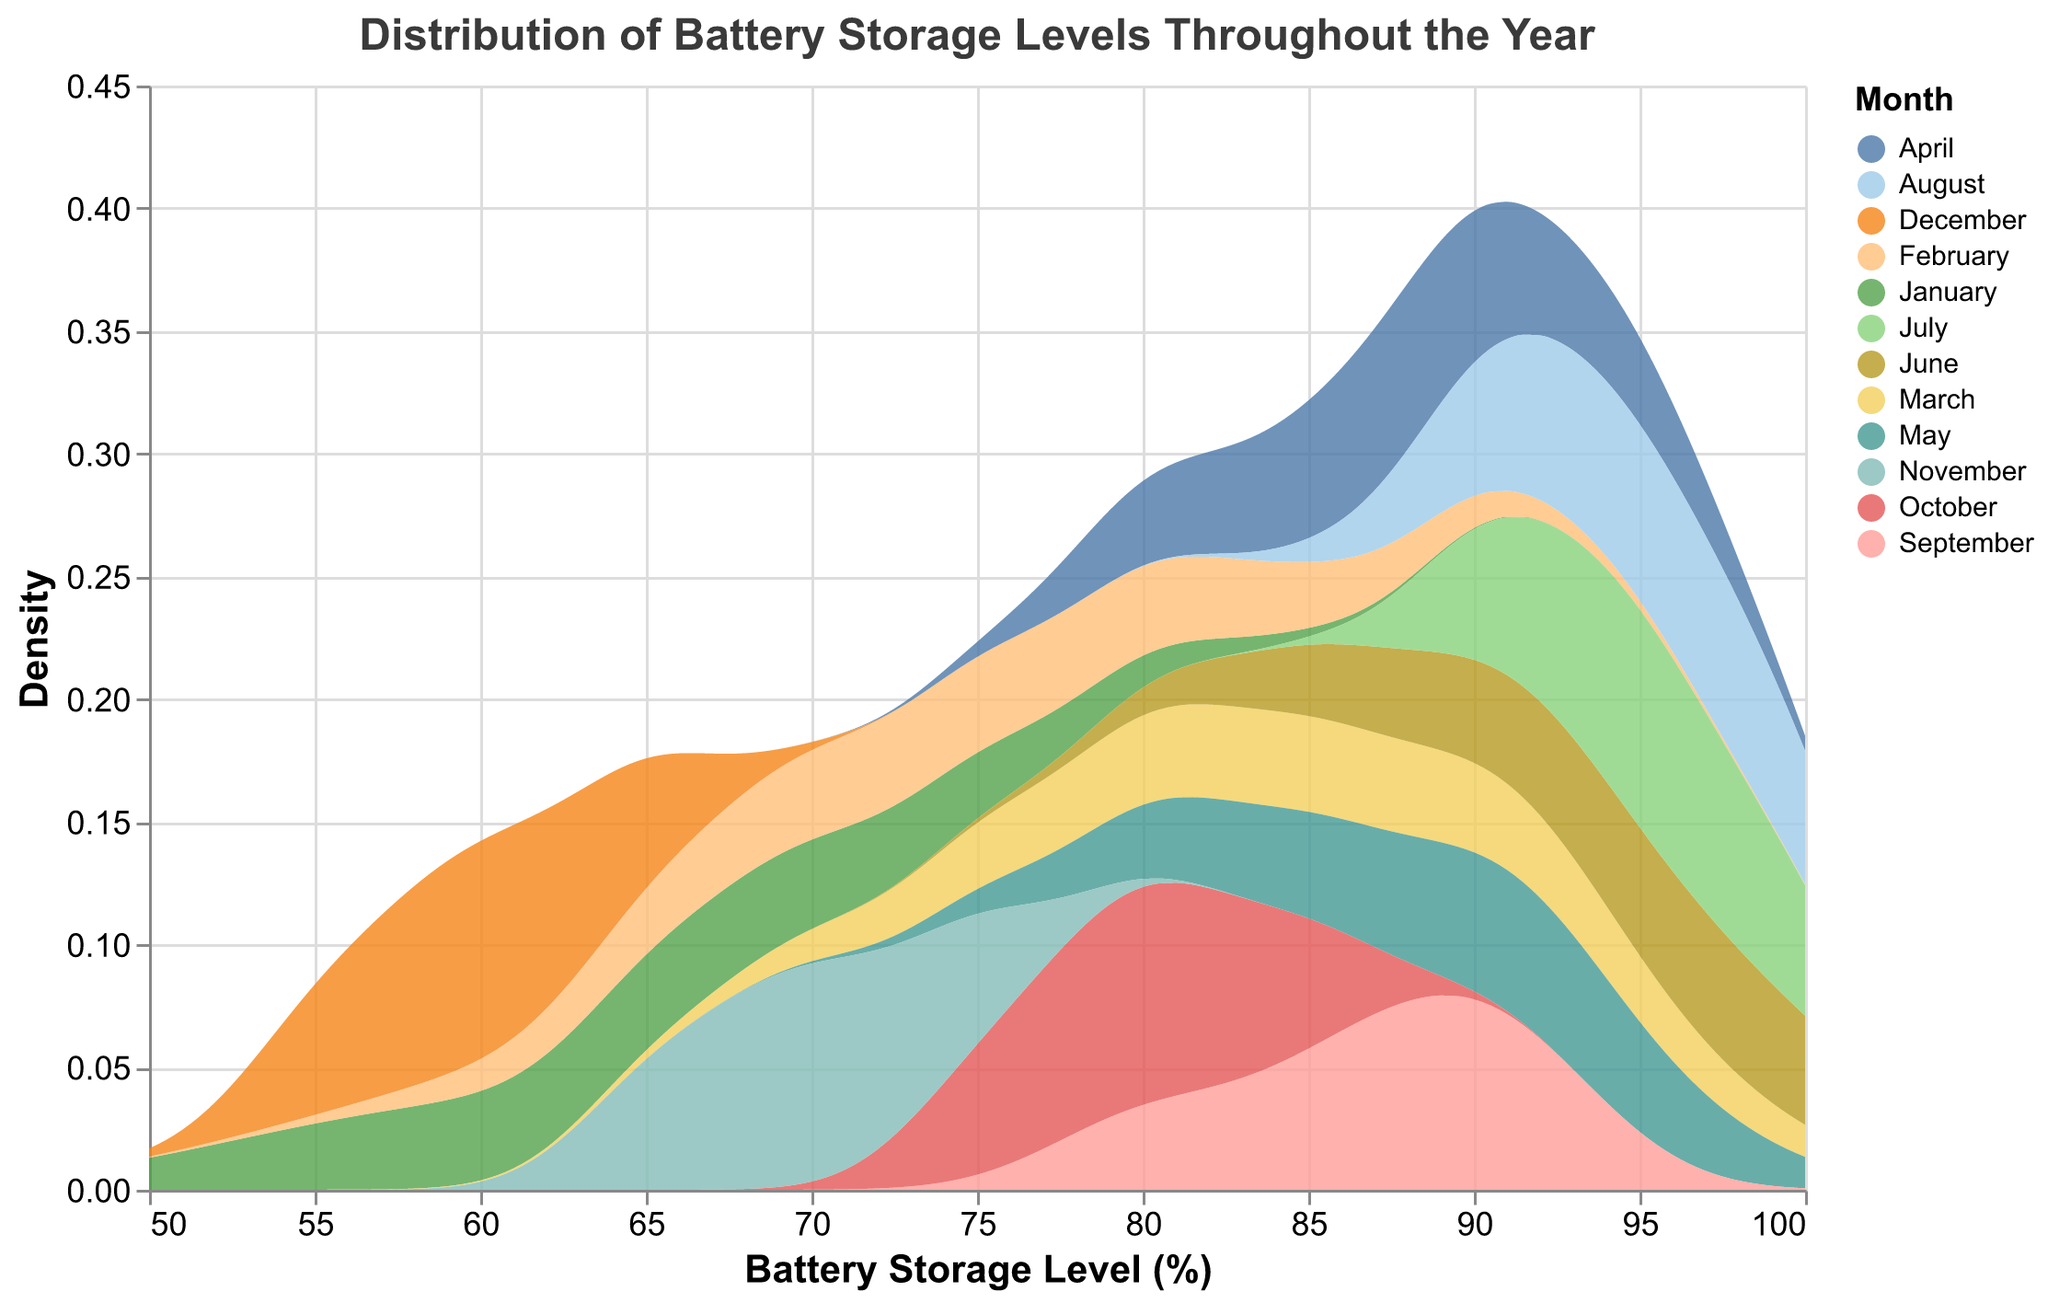What is the title of the plot? The title is displayed at the top of the plot and reads "Distribution of Battery Storage Levels Throughout the Year."
Answer: Distribution of Battery Storage Levels Throughout the Year What does the x-axis represent in the plot? The x-axis label shows "Battery Storage Level (%)" indicating that the x-axis represents the percentage level of battery storage.
Answer: Battery Storage Level (%) What is the color used to represent each month? The legend on the right side of the plot specifies the color representation for each month.
Answer: Various colors specified by the legend Which month shows the highest density of battery storage levels around 100%? Looking at the peak of density curves around the 100% mark, both June, July, and August have peaks, implying these months have high densities at 100%.
Answer: June, July, and August During which months do battery storage levels show the lowest density values around 55%? Referring to the density curves near the 55% mark, January and December show curves starting near 55% but with lower density values, indicating lower occurrences.
Answer: January and December What can be inferred about battery storage levels in summer months (June, July, and August)? The density curves for June, July, and August are higher and shift towards the upper end (near 100%), indicating higher battery storage levels during summer months.
Answer: Higher battery storage levels Which months exhibit battery storage levels with a prominent peak at around 85%? By observing the density curves, April and September show notable peaks around the 85% level.
Answer: April and September How does the variability of battery storage levels in December compare to those in March? December's density curve shows a narrower range and lower densities compared to March, which shows wider distribution peaks around mid and upper levels.
Answer: December has lower variability compared to March In which month does the density of battery storage levels hover around 70% most prominently? The density curve for November prominently peaks around the 70% mark, indicating higher frequency at this level.
Answer: November How do the battery storage levels in spring (March, April, May) compare to those in fall (September, October, November)? The spring months show wider variability and generally higher battery storage levels compared to fall months which display more moderate storage levels.
Answer: Spring has higher and more variable levels than Fall 